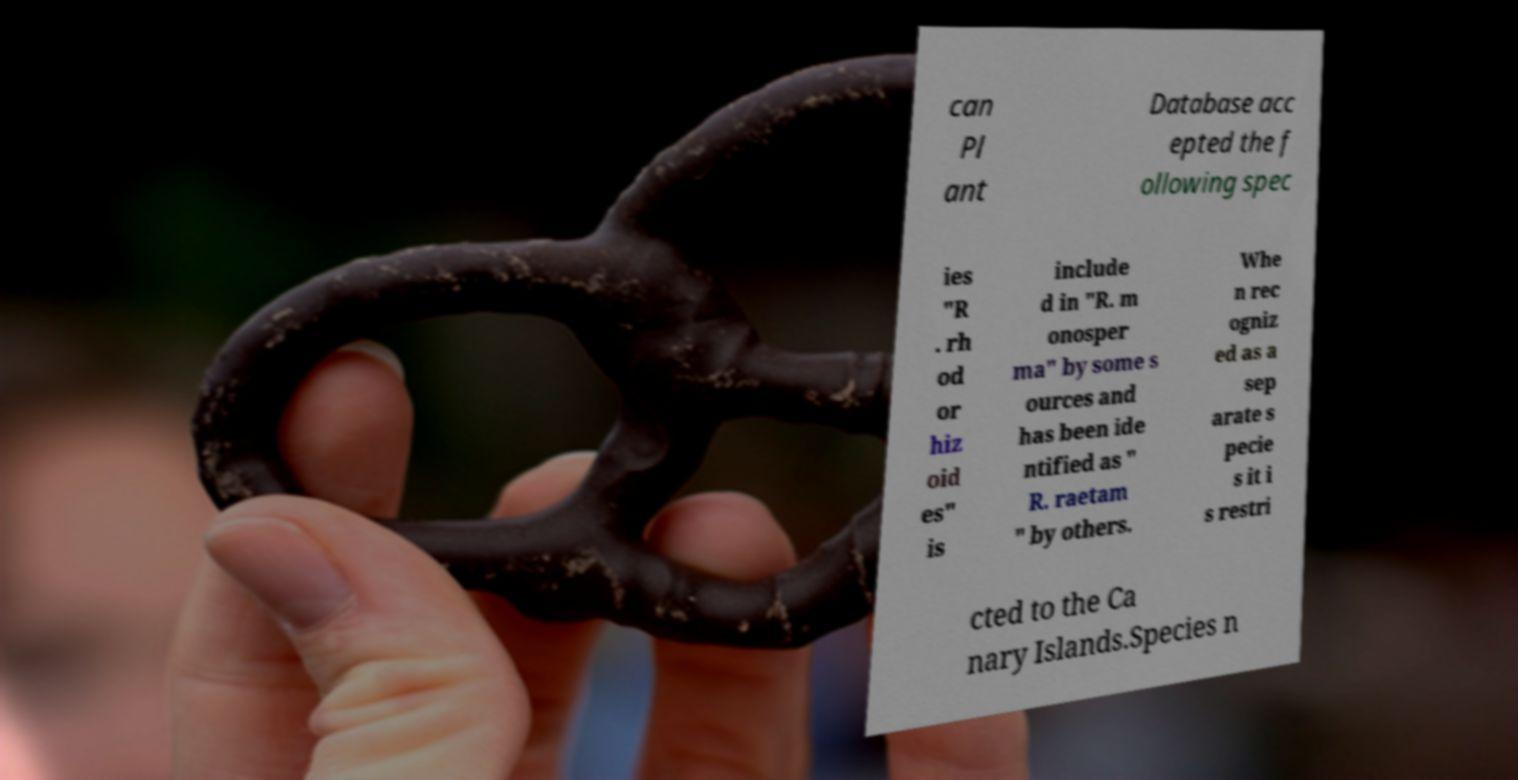There's text embedded in this image that I need extracted. Can you transcribe it verbatim? can Pl ant Database acc epted the f ollowing spec ies "R . rh od or hiz oid es" is include d in "R. m onosper ma" by some s ources and has been ide ntified as " R. raetam " by others. Whe n rec ogniz ed as a sep arate s pecie s it i s restri cted to the Ca nary Islands.Species n 